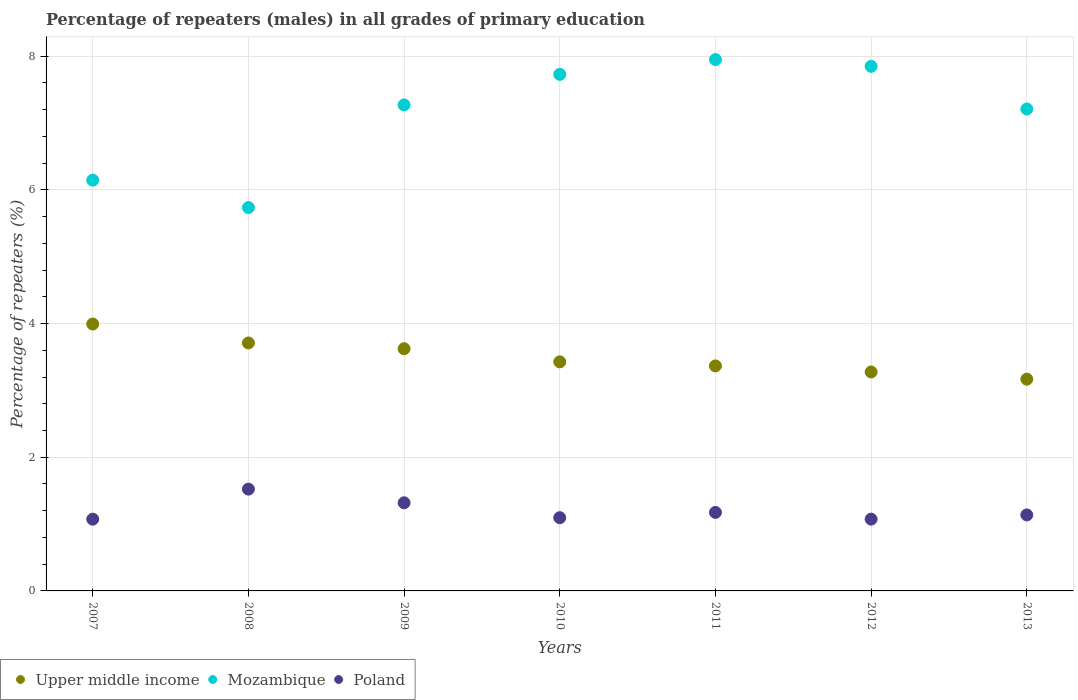What is the percentage of repeaters (males) in Mozambique in 2009?
Your answer should be compact. 7.27. Across all years, what is the maximum percentage of repeaters (males) in Mozambique?
Your answer should be very brief. 7.95. Across all years, what is the minimum percentage of repeaters (males) in Mozambique?
Provide a succinct answer. 5.74. What is the total percentage of repeaters (males) in Upper middle income in the graph?
Ensure brevity in your answer.  24.56. What is the difference between the percentage of repeaters (males) in Upper middle income in 2007 and that in 2011?
Your answer should be very brief. 0.63. What is the difference between the percentage of repeaters (males) in Poland in 2012 and the percentage of repeaters (males) in Mozambique in 2008?
Provide a succinct answer. -4.66. What is the average percentage of repeaters (males) in Upper middle income per year?
Offer a terse response. 3.51. In the year 2013, what is the difference between the percentage of repeaters (males) in Mozambique and percentage of repeaters (males) in Poland?
Make the answer very short. 6.07. What is the ratio of the percentage of repeaters (males) in Upper middle income in 2007 to that in 2011?
Your response must be concise. 1.19. Is the difference between the percentage of repeaters (males) in Mozambique in 2010 and 2012 greater than the difference between the percentage of repeaters (males) in Poland in 2010 and 2012?
Ensure brevity in your answer.  No. What is the difference between the highest and the second highest percentage of repeaters (males) in Mozambique?
Give a very brief answer. 0.1. What is the difference between the highest and the lowest percentage of repeaters (males) in Poland?
Your response must be concise. 0.45. Does the percentage of repeaters (males) in Mozambique monotonically increase over the years?
Make the answer very short. No. Is the percentage of repeaters (males) in Mozambique strictly less than the percentage of repeaters (males) in Poland over the years?
Keep it short and to the point. No. How many dotlines are there?
Give a very brief answer. 3. What is the difference between two consecutive major ticks on the Y-axis?
Provide a short and direct response. 2. Are the values on the major ticks of Y-axis written in scientific E-notation?
Offer a very short reply. No. Does the graph contain any zero values?
Provide a short and direct response. No. Does the graph contain grids?
Your answer should be compact. Yes. Where does the legend appear in the graph?
Provide a succinct answer. Bottom left. How many legend labels are there?
Make the answer very short. 3. What is the title of the graph?
Offer a very short reply. Percentage of repeaters (males) in all grades of primary education. Does "Bermuda" appear as one of the legend labels in the graph?
Offer a terse response. No. What is the label or title of the X-axis?
Your response must be concise. Years. What is the label or title of the Y-axis?
Ensure brevity in your answer.  Percentage of repeaters (%). What is the Percentage of repeaters (%) of Upper middle income in 2007?
Provide a succinct answer. 3.99. What is the Percentage of repeaters (%) in Mozambique in 2007?
Your answer should be very brief. 6.14. What is the Percentage of repeaters (%) in Poland in 2007?
Your response must be concise. 1.07. What is the Percentage of repeaters (%) in Upper middle income in 2008?
Offer a terse response. 3.71. What is the Percentage of repeaters (%) of Mozambique in 2008?
Your answer should be compact. 5.74. What is the Percentage of repeaters (%) in Poland in 2008?
Provide a short and direct response. 1.52. What is the Percentage of repeaters (%) in Upper middle income in 2009?
Your answer should be compact. 3.62. What is the Percentage of repeaters (%) of Mozambique in 2009?
Provide a short and direct response. 7.27. What is the Percentage of repeaters (%) of Poland in 2009?
Your response must be concise. 1.32. What is the Percentage of repeaters (%) of Upper middle income in 2010?
Your answer should be very brief. 3.43. What is the Percentage of repeaters (%) in Mozambique in 2010?
Ensure brevity in your answer.  7.73. What is the Percentage of repeaters (%) of Poland in 2010?
Offer a terse response. 1.1. What is the Percentage of repeaters (%) in Upper middle income in 2011?
Ensure brevity in your answer.  3.37. What is the Percentage of repeaters (%) of Mozambique in 2011?
Your answer should be compact. 7.95. What is the Percentage of repeaters (%) of Poland in 2011?
Keep it short and to the point. 1.17. What is the Percentage of repeaters (%) in Upper middle income in 2012?
Ensure brevity in your answer.  3.28. What is the Percentage of repeaters (%) of Mozambique in 2012?
Provide a succinct answer. 7.85. What is the Percentage of repeaters (%) of Poland in 2012?
Ensure brevity in your answer.  1.07. What is the Percentage of repeaters (%) in Upper middle income in 2013?
Provide a succinct answer. 3.17. What is the Percentage of repeaters (%) of Mozambique in 2013?
Offer a terse response. 7.21. What is the Percentage of repeaters (%) in Poland in 2013?
Make the answer very short. 1.14. Across all years, what is the maximum Percentage of repeaters (%) of Upper middle income?
Make the answer very short. 3.99. Across all years, what is the maximum Percentage of repeaters (%) of Mozambique?
Offer a terse response. 7.95. Across all years, what is the maximum Percentage of repeaters (%) of Poland?
Your answer should be compact. 1.52. Across all years, what is the minimum Percentage of repeaters (%) in Upper middle income?
Your answer should be very brief. 3.17. Across all years, what is the minimum Percentage of repeaters (%) in Mozambique?
Your answer should be compact. 5.74. Across all years, what is the minimum Percentage of repeaters (%) in Poland?
Your response must be concise. 1.07. What is the total Percentage of repeaters (%) of Upper middle income in the graph?
Keep it short and to the point. 24.56. What is the total Percentage of repeaters (%) in Mozambique in the graph?
Keep it short and to the point. 49.89. What is the total Percentage of repeaters (%) of Poland in the graph?
Ensure brevity in your answer.  8.4. What is the difference between the Percentage of repeaters (%) of Upper middle income in 2007 and that in 2008?
Your answer should be compact. 0.28. What is the difference between the Percentage of repeaters (%) in Mozambique in 2007 and that in 2008?
Provide a short and direct response. 0.41. What is the difference between the Percentage of repeaters (%) of Poland in 2007 and that in 2008?
Make the answer very short. -0.45. What is the difference between the Percentage of repeaters (%) of Upper middle income in 2007 and that in 2009?
Provide a short and direct response. 0.37. What is the difference between the Percentage of repeaters (%) in Mozambique in 2007 and that in 2009?
Offer a terse response. -1.13. What is the difference between the Percentage of repeaters (%) of Poland in 2007 and that in 2009?
Provide a short and direct response. -0.24. What is the difference between the Percentage of repeaters (%) of Upper middle income in 2007 and that in 2010?
Ensure brevity in your answer.  0.57. What is the difference between the Percentage of repeaters (%) of Mozambique in 2007 and that in 2010?
Ensure brevity in your answer.  -1.58. What is the difference between the Percentage of repeaters (%) in Poland in 2007 and that in 2010?
Make the answer very short. -0.02. What is the difference between the Percentage of repeaters (%) of Upper middle income in 2007 and that in 2011?
Make the answer very short. 0.63. What is the difference between the Percentage of repeaters (%) of Mozambique in 2007 and that in 2011?
Offer a terse response. -1.8. What is the difference between the Percentage of repeaters (%) of Poland in 2007 and that in 2011?
Keep it short and to the point. -0.1. What is the difference between the Percentage of repeaters (%) in Upper middle income in 2007 and that in 2012?
Offer a very short reply. 0.72. What is the difference between the Percentage of repeaters (%) of Mozambique in 2007 and that in 2012?
Give a very brief answer. -1.7. What is the difference between the Percentage of repeaters (%) of Poland in 2007 and that in 2012?
Provide a succinct answer. -0. What is the difference between the Percentage of repeaters (%) in Upper middle income in 2007 and that in 2013?
Your response must be concise. 0.82. What is the difference between the Percentage of repeaters (%) of Mozambique in 2007 and that in 2013?
Give a very brief answer. -1.06. What is the difference between the Percentage of repeaters (%) of Poland in 2007 and that in 2013?
Ensure brevity in your answer.  -0.06. What is the difference between the Percentage of repeaters (%) in Upper middle income in 2008 and that in 2009?
Ensure brevity in your answer.  0.09. What is the difference between the Percentage of repeaters (%) of Mozambique in 2008 and that in 2009?
Give a very brief answer. -1.54. What is the difference between the Percentage of repeaters (%) in Poland in 2008 and that in 2009?
Offer a terse response. 0.2. What is the difference between the Percentage of repeaters (%) in Upper middle income in 2008 and that in 2010?
Your answer should be very brief. 0.28. What is the difference between the Percentage of repeaters (%) in Mozambique in 2008 and that in 2010?
Your answer should be very brief. -1.99. What is the difference between the Percentage of repeaters (%) in Poland in 2008 and that in 2010?
Make the answer very short. 0.43. What is the difference between the Percentage of repeaters (%) in Upper middle income in 2008 and that in 2011?
Your response must be concise. 0.34. What is the difference between the Percentage of repeaters (%) in Mozambique in 2008 and that in 2011?
Your answer should be very brief. -2.21. What is the difference between the Percentage of repeaters (%) of Poland in 2008 and that in 2011?
Provide a short and direct response. 0.35. What is the difference between the Percentage of repeaters (%) in Upper middle income in 2008 and that in 2012?
Your answer should be compact. 0.43. What is the difference between the Percentage of repeaters (%) in Mozambique in 2008 and that in 2012?
Your answer should be very brief. -2.11. What is the difference between the Percentage of repeaters (%) of Poland in 2008 and that in 2012?
Offer a terse response. 0.45. What is the difference between the Percentage of repeaters (%) in Upper middle income in 2008 and that in 2013?
Offer a terse response. 0.54. What is the difference between the Percentage of repeaters (%) of Mozambique in 2008 and that in 2013?
Your response must be concise. -1.47. What is the difference between the Percentage of repeaters (%) of Poland in 2008 and that in 2013?
Ensure brevity in your answer.  0.39. What is the difference between the Percentage of repeaters (%) in Upper middle income in 2009 and that in 2010?
Your response must be concise. 0.2. What is the difference between the Percentage of repeaters (%) in Mozambique in 2009 and that in 2010?
Offer a terse response. -0.46. What is the difference between the Percentage of repeaters (%) in Poland in 2009 and that in 2010?
Keep it short and to the point. 0.22. What is the difference between the Percentage of repeaters (%) of Upper middle income in 2009 and that in 2011?
Your response must be concise. 0.26. What is the difference between the Percentage of repeaters (%) of Mozambique in 2009 and that in 2011?
Offer a terse response. -0.68. What is the difference between the Percentage of repeaters (%) of Poland in 2009 and that in 2011?
Provide a short and direct response. 0.14. What is the difference between the Percentage of repeaters (%) in Upper middle income in 2009 and that in 2012?
Offer a very short reply. 0.35. What is the difference between the Percentage of repeaters (%) in Mozambique in 2009 and that in 2012?
Give a very brief answer. -0.58. What is the difference between the Percentage of repeaters (%) in Poland in 2009 and that in 2012?
Offer a very short reply. 0.24. What is the difference between the Percentage of repeaters (%) in Upper middle income in 2009 and that in 2013?
Provide a succinct answer. 0.46. What is the difference between the Percentage of repeaters (%) in Mozambique in 2009 and that in 2013?
Keep it short and to the point. 0.06. What is the difference between the Percentage of repeaters (%) of Poland in 2009 and that in 2013?
Provide a succinct answer. 0.18. What is the difference between the Percentage of repeaters (%) in Upper middle income in 2010 and that in 2011?
Your answer should be very brief. 0.06. What is the difference between the Percentage of repeaters (%) of Mozambique in 2010 and that in 2011?
Make the answer very short. -0.22. What is the difference between the Percentage of repeaters (%) in Poland in 2010 and that in 2011?
Ensure brevity in your answer.  -0.08. What is the difference between the Percentage of repeaters (%) in Upper middle income in 2010 and that in 2012?
Make the answer very short. 0.15. What is the difference between the Percentage of repeaters (%) in Mozambique in 2010 and that in 2012?
Keep it short and to the point. -0.12. What is the difference between the Percentage of repeaters (%) in Poland in 2010 and that in 2012?
Offer a very short reply. 0.02. What is the difference between the Percentage of repeaters (%) in Upper middle income in 2010 and that in 2013?
Your response must be concise. 0.26. What is the difference between the Percentage of repeaters (%) of Mozambique in 2010 and that in 2013?
Your answer should be compact. 0.52. What is the difference between the Percentage of repeaters (%) of Poland in 2010 and that in 2013?
Provide a succinct answer. -0.04. What is the difference between the Percentage of repeaters (%) of Upper middle income in 2011 and that in 2012?
Provide a succinct answer. 0.09. What is the difference between the Percentage of repeaters (%) in Mozambique in 2011 and that in 2012?
Your answer should be compact. 0.1. What is the difference between the Percentage of repeaters (%) of Poland in 2011 and that in 2012?
Make the answer very short. 0.1. What is the difference between the Percentage of repeaters (%) of Upper middle income in 2011 and that in 2013?
Offer a very short reply. 0.2. What is the difference between the Percentage of repeaters (%) in Mozambique in 2011 and that in 2013?
Your answer should be compact. 0.74. What is the difference between the Percentage of repeaters (%) in Poland in 2011 and that in 2013?
Your answer should be very brief. 0.04. What is the difference between the Percentage of repeaters (%) in Upper middle income in 2012 and that in 2013?
Keep it short and to the point. 0.11. What is the difference between the Percentage of repeaters (%) of Mozambique in 2012 and that in 2013?
Offer a very short reply. 0.64. What is the difference between the Percentage of repeaters (%) of Poland in 2012 and that in 2013?
Offer a terse response. -0.06. What is the difference between the Percentage of repeaters (%) in Upper middle income in 2007 and the Percentage of repeaters (%) in Mozambique in 2008?
Offer a terse response. -1.74. What is the difference between the Percentage of repeaters (%) in Upper middle income in 2007 and the Percentage of repeaters (%) in Poland in 2008?
Your answer should be very brief. 2.47. What is the difference between the Percentage of repeaters (%) of Mozambique in 2007 and the Percentage of repeaters (%) of Poland in 2008?
Your response must be concise. 4.62. What is the difference between the Percentage of repeaters (%) of Upper middle income in 2007 and the Percentage of repeaters (%) of Mozambique in 2009?
Your answer should be compact. -3.28. What is the difference between the Percentage of repeaters (%) in Upper middle income in 2007 and the Percentage of repeaters (%) in Poland in 2009?
Give a very brief answer. 2.67. What is the difference between the Percentage of repeaters (%) in Mozambique in 2007 and the Percentage of repeaters (%) in Poland in 2009?
Ensure brevity in your answer.  4.83. What is the difference between the Percentage of repeaters (%) in Upper middle income in 2007 and the Percentage of repeaters (%) in Mozambique in 2010?
Keep it short and to the point. -3.73. What is the difference between the Percentage of repeaters (%) in Upper middle income in 2007 and the Percentage of repeaters (%) in Poland in 2010?
Make the answer very short. 2.9. What is the difference between the Percentage of repeaters (%) of Mozambique in 2007 and the Percentage of repeaters (%) of Poland in 2010?
Offer a very short reply. 5.05. What is the difference between the Percentage of repeaters (%) of Upper middle income in 2007 and the Percentage of repeaters (%) of Mozambique in 2011?
Ensure brevity in your answer.  -3.96. What is the difference between the Percentage of repeaters (%) of Upper middle income in 2007 and the Percentage of repeaters (%) of Poland in 2011?
Provide a succinct answer. 2.82. What is the difference between the Percentage of repeaters (%) of Mozambique in 2007 and the Percentage of repeaters (%) of Poland in 2011?
Provide a short and direct response. 4.97. What is the difference between the Percentage of repeaters (%) of Upper middle income in 2007 and the Percentage of repeaters (%) of Mozambique in 2012?
Offer a terse response. -3.86. What is the difference between the Percentage of repeaters (%) in Upper middle income in 2007 and the Percentage of repeaters (%) in Poland in 2012?
Give a very brief answer. 2.92. What is the difference between the Percentage of repeaters (%) in Mozambique in 2007 and the Percentage of repeaters (%) in Poland in 2012?
Provide a short and direct response. 5.07. What is the difference between the Percentage of repeaters (%) of Upper middle income in 2007 and the Percentage of repeaters (%) of Mozambique in 2013?
Your response must be concise. -3.22. What is the difference between the Percentage of repeaters (%) of Upper middle income in 2007 and the Percentage of repeaters (%) of Poland in 2013?
Give a very brief answer. 2.86. What is the difference between the Percentage of repeaters (%) in Mozambique in 2007 and the Percentage of repeaters (%) in Poland in 2013?
Provide a short and direct response. 5.01. What is the difference between the Percentage of repeaters (%) of Upper middle income in 2008 and the Percentage of repeaters (%) of Mozambique in 2009?
Your answer should be very brief. -3.56. What is the difference between the Percentage of repeaters (%) in Upper middle income in 2008 and the Percentage of repeaters (%) in Poland in 2009?
Offer a terse response. 2.39. What is the difference between the Percentage of repeaters (%) in Mozambique in 2008 and the Percentage of repeaters (%) in Poland in 2009?
Provide a short and direct response. 4.42. What is the difference between the Percentage of repeaters (%) of Upper middle income in 2008 and the Percentage of repeaters (%) of Mozambique in 2010?
Your response must be concise. -4.02. What is the difference between the Percentage of repeaters (%) in Upper middle income in 2008 and the Percentage of repeaters (%) in Poland in 2010?
Your answer should be very brief. 2.61. What is the difference between the Percentage of repeaters (%) of Mozambique in 2008 and the Percentage of repeaters (%) of Poland in 2010?
Provide a succinct answer. 4.64. What is the difference between the Percentage of repeaters (%) of Upper middle income in 2008 and the Percentage of repeaters (%) of Mozambique in 2011?
Ensure brevity in your answer.  -4.24. What is the difference between the Percentage of repeaters (%) of Upper middle income in 2008 and the Percentage of repeaters (%) of Poland in 2011?
Your answer should be very brief. 2.53. What is the difference between the Percentage of repeaters (%) in Mozambique in 2008 and the Percentage of repeaters (%) in Poland in 2011?
Your answer should be very brief. 4.56. What is the difference between the Percentage of repeaters (%) in Upper middle income in 2008 and the Percentage of repeaters (%) in Mozambique in 2012?
Your response must be concise. -4.14. What is the difference between the Percentage of repeaters (%) of Upper middle income in 2008 and the Percentage of repeaters (%) of Poland in 2012?
Your response must be concise. 2.64. What is the difference between the Percentage of repeaters (%) of Mozambique in 2008 and the Percentage of repeaters (%) of Poland in 2012?
Provide a short and direct response. 4.66. What is the difference between the Percentage of repeaters (%) of Upper middle income in 2008 and the Percentage of repeaters (%) of Mozambique in 2013?
Your answer should be compact. -3.5. What is the difference between the Percentage of repeaters (%) in Upper middle income in 2008 and the Percentage of repeaters (%) in Poland in 2013?
Make the answer very short. 2.57. What is the difference between the Percentage of repeaters (%) of Mozambique in 2008 and the Percentage of repeaters (%) of Poland in 2013?
Provide a short and direct response. 4.6. What is the difference between the Percentage of repeaters (%) of Upper middle income in 2009 and the Percentage of repeaters (%) of Mozambique in 2010?
Your response must be concise. -4.1. What is the difference between the Percentage of repeaters (%) of Upper middle income in 2009 and the Percentage of repeaters (%) of Poland in 2010?
Offer a very short reply. 2.53. What is the difference between the Percentage of repeaters (%) in Mozambique in 2009 and the Percentage of repeaters (%) in Poland in 2010?
Provide a succinct answer. 6.18. What is the difference between the Percentage of repeaters (%) of Upper middle income in 2009 and the Percentage of repeaters (%) of Mozambique in 2011?
Provide a short and direct response. -4.33. What is the difference between the Percentage of repeaters (%) of Upper middle income in 2009 and the Percentage of repeaters (%) of Poland in 2011?
Give a very brief answer. 2.45. What is the difference between the Percentage of repeaters (%) in Mozambique in 2009 and the Percentage of repeaters (%) in Poland in 2011?
Ensure brevity in your answer.  6.1. What is the difference between the Percentage of repeaters (%) of Upper middle income in 2009 and the Percentage of repeaters (%) of Mozambique in 2012?
Ensure brevity in your answer.  -4.22. What is the difference between the Percentage of repeaters (%) in Upper middle income in 2009 and the Percentage of repeaters (%) in Poland in 2012?
Provide a succinct answer. 2.55. What is the difference between the Percentage of repeaters (%) of Mozambique in 2009 and the Percentage of repeaters (%) of Poland in 2012?
Offer a very short reply. 6.2. What is the difference between the Percentage of repeaters (%) in Upper middle income in 2009 and the Percentage of repeaters (%) in Mozambique in 2013?
Your answer should be compact. -3.59. What is the difference between the Percentage of repeaters (%) of Upper middle income in 2009 and the Percentage of repeaters (%) of Poland in 2013?
Make the answer very short. 2.49. What is the difference between the Percentage of repeaters (%) of Mozambique in 2009 and the Percentage of repeaters (%) of Poland in 2013?
Offer a very short reply. 6.13. What is the difference between the Percentage of repeaters (%) in Upper middle income in 2010 and the Percentage of repeaters (%) in Mozambique in 2011?
Give a very brief answer. -4.52. What is the difference between the Percentage of repeaters (%) in Upper middle income in 2010 and the Percentage of repeaters (%) in Poland in 2011?
Keep it short and to the point. 2.25. What is the difference between the Percentage of repeaters (%) of Mozambique in 2010 and the Percentage of repeaters (%) of Poland in 2011?
Make the answer very short. 6.55. What is the difference between the Percentage of repeaters (%) of Upper middle income in 2010 and the Percentage of repeaters (%) of Mozambique in 2012?
Your answer should be compact. -4.42. What is the difference between the Percentage of repeaters (%) in Upper middle income in 2010 and the Percentage of repeaters (%) in Poland in 2012?
Make the answer very short. 2.35. What is the difference between the Percentage of repeaters (%) of Mozambique in 2010 and the Percentage of repeaters (%) of Poland in 2012?
Ensure brevity in your answer.  6.65. What is the difference between the Percentage of repeaters (%) in Upper middle income in 2010 and the Percentage of repeaters (%) in Mozambique in 2013?
Give a very brief answer. -3.78. What is the difference between the Percentage of repeaters (%) of Upper middle income in 2010 and the Percentage of repeaters (%) of Poland in 2013?
Ensure brevity in your answer.  2.29. What is the difference between the Percentage of repeaters (%) in Mozambique in 2010 and the Percentage of repeaters (%) in Poland in 2013?
Give a very brief answer. 6.59. What is the difference between the Percentage of repeaters (%) of Upper middle income in 2011 and the Percentage of repeaters (%) of Mozambique in 2012?
Ensure brevity in your answer.  -4.48. What is the difference between the Percentage of repeaters (%) of Upper middle income in 2011 and the Percentage of repeaters (%) of Poland in 2012?
Offer a very short reply. 2.29. What is the difference between the Percentage of repeaters (%) in Mozambique in 2011 and the Percentage of repeaters (%) in Poland in 2012?
Offer a terse response. 6.88. What is the difference between the Percentage of repeaters (%) of Upper middle income in 2011 and the Percentage of repeaters (%) of Mozambique in 2013?
Your response must be concise. -3.84. What is the difference between the Percentage of repeaters (%) in Upper middle income in 2011 and the Percentage of repeaters (%) in Poland in 2013?
Ensure brevity in your answer.  2.23. What is the difference between the Percentage of repeaters (%) in Mozambique in 2011 and the Percentage of repeaters (%) in Poland in 2013?
Make the answer very short. 6.81. What is the difference between the Percentage of repeaters (%) of Upper middle income in 2012 and the Percentage of repeaters (%) of Mozambique in 2013?
Ensure brevity in your answer.  -3.93. What is the difference between the Percentage of repeaters (%) of Upper middle income in 2012 and the Percentage of repeaters (%) of Poland in 2013?
Provide a succinct answer. 2.14. What is the difference between the Percentage of repeaters (%) of Mozambique in 2012 and the Percentage of repeaters (%) of Poland in 2013?
Make the answer very short. 6.71. What is the average Percentage of repeaters (%) of Upper middle income per year?
Your response must be concise. 3.51. What is the average Percentage of repeaters (%) in Mozambique per year?
Make the answer very short. 7.13. What is the average Percentage of repeaters (%) in Poland per year?
Your answer should be compact. 1.2. In the year 2007, what is the difference between the Percentage of repeaters (%) of Upper middle income and Percentage of repeaters (%) of Mozambique?
Ensure brevity in your answer.  -2.15. In the year 2007, what is the difference between the Percentage of repeaters (%) in Upper middle income and Percentage of repeaters (%) in Poland?
Offer a terse response. 2.92. In the year 2007, what is the difference between the Percentage of repeaters (%) in Mozambique and Percentage of repeaters (%) in Poland?
Keep it short and to the point. 5.07. In the year 2008, what is the difference between the Percentage of repeaters (%) in Upper middle income and Percentage of repeaters (%) in Mozambique?
Offer a very short reply. -2.03. In the year 2008, what is the difference between the Percentage of repeaters (%) in Upper middle income and Percentage of repeaters (%) in Poland?
Provide a succinct answer. 2.19. In the year 2008, what is the difference between the Percentage of repeaters (%) of Mozambique and Percentage of repeaters (%) of Poland?
Keep it short and to the point. 4.21. In the year 2009, what is the difference between the Percentage of repeaters (%) of Upper middle income and Percentage of repeaters (%) of Mozambique?
Ensure brevity in your answer.  -3.65. In the year 2009, what is the difference between the Percentage of repeaters (%) in Upper middle income and Percentage of repeaters (%) in Poland?
Make the answer very short. 2.3. In the year 2009, what is the difference between the Percentage of repeaters (%) of Mozambique and Percentage of repeaters (%) of Poland?
Keep it short and to the point. 5.95. In the year 2010, what is the difference between the Percentage of repeaters (%) in Upper middle income and Percentage of repeaters (%) in Mozambique?
Give a very brief answer. -4.3. In the year 2010, what is the difference between the Percentage of repeaters (%) of Upper middle income and Percentage of repeaters (%) of Poland?
Provide a succinct answer. 2.33. In the year 2010, what is the difference between the Percentage of repeaters (%) of Mozambique and Percentage of repeaters (%) of Poland?
Provide a short and direct response. 6.63. In the year 2011, what is the difference between the Percentage of repeaters (%) of Upper middle income and Percentage of repeaters (%) of Mozambique?
Your response must be concise. -4.58. In the year 2011, what is the difference between the Percentage of repeaters (%) in Upper middle income and Percentage of repeaters (%) in Poland?
Your response must be concise. 2.19. In the year 2011, what is the difference between the Percentage of repeaters (%) in Mozambique and Percentage of repeaters (%) in Poland?
Your answer should be compact. 6.77. In the year 2012, what is the difference between the Percentage of repeaters (%) in Upper middle income and Percentage of repeaters (%) in Mozambique?
Provide a succinct answer. -4.57. In the year 2012, what is the difference between the Percentage of repeaters (%) in Upper middle income and Percentage of repeaters (%) in Poland?
Ensure brevity in your answer.  2.2. In the year 2012, what is the difference between the Percentage of repeaters (%) of Mozambique and Percentage of repeaters (%) of Poland?
Your answer should be compact. 6.77. In the year 2013, what is the difference between the Percentage of repeaters (%) of Upper middle income and Percentage of repeaters (%) of Mozambique?
Provide a succinct answer. -4.04. In the year 2013, what is the difference between the Percentage of repeaters (%) of Upper middle income and Percentage of repeaters (%) of Poland?
Your answer should be compact. 2.03. In the year 2013, what is the difference between the Percentage of repeaters (%) in Mozambique and Percentage of repeaters (%) in Poland?
Offer a terse response. 6.07. What is the ratio of the Percentage of repeaters (%) of Upper middle income in 2007 to that in 2008?
Offer a very short reply. 1.08. What is the ratio of the Percentage of repeaters (%) of Mozambique in 2007 to that in 2008?
Make the answer very short. 1.07. What is the ratio of the Percentage of repeaters (%) in Poland in 2007 to that in 2008?
Offer a terse response. 0.7. What is the ratio of the Percentage of repeaters (%) of Upper middle income in 2007 to that in 2009?
Your response must be concise. 1.1. What is the ratio of the Percentage of repeaters (%) in Mozambique in 2007 to that in 2009?
Give a very brief answer. 0.85. What is the ratio of the Percentage of repeaters (%) of Poland in 2007 to that in 2009?
Offer a terse response. 0.81. What is the ratio of the Percentage of repeaters (%) of Upper middle income in 2007 to that in 2010?
Offer a very short reply. 1.17. What is the ratio of the Percentage of repeaters (%) in Mozambique in 2007 to that in 2010?
Keep it short and to the point. 0.8. What is the ratio of the Percentage of repeaters (%) in Poland in 2007 to that in 2010?
Offer a terse response. 0.98. What is the ratio of the Percentage of repeaters (%) of Upper middle income in 2007 to that in 2011?
Your answer should be very brief. 1.19. What is the ratio of the Percentage of repeaters (%) in Mozambique in 2007 to that in 2011?
Your answer should be very brief. 0.77. What is the ratio of the Percentage of repeaters (%) of Poland in 2007 to that in 2011?
Your answer should be compact. 0.91. What is the ratio of the Percentage of repeaters (%) in Upper middle income in 2007 to that in 2012?
Provide a succinct answer. 1.22. What is the ratio of the Percentage of repeaters (%) of Mozambique in 2007 to that in 2012?
Give a very brief answer. 0.78. What is the ratio of the Percentage of repeaters (%) of Upper middle income in 2007 to that in 2013?
Give a very brief answer. 1.26. What is the ratio of the Percentage of repeaters (%) in Mozambique in 2007 to that in 2013?
Your response must be concise. 0.85. What is the ratio of the Percentage of repeaters (%) of Poland in 2007 to that in 2013?
Provide a short and direct response. 0.94. What is the ratio of the Percentage of repeaters (%) of Upper middle income in 2008 to that in 2009?
Provide a short and direct response. 1.02. What is the ratio of the Percentage of repeaters (%) of Mozambique in 2008 to that in 2009?
Give a very brief answer. 0.79. What is the ratio of the Percentage of repeaters (%) of Poland in 2008 to that in 2009?
Your response must be concise. 1.16. What is the ratio of the Percentage of repeaters (%) of Upper middle income in 2008 to that in 2010?
Your response must be concise. 1.08. What is the ratio of the Percentage of repeaters (%) in Mozambique in 2008 to that in 2010?
Provide a succinct answer. 0.74. What is the ratio of the Percentage of repeaters (%) of Poland in 2008 to that in 2010?
Your answer should be compact. 1.39. What is the ratio of the Percentage of repeaters (%) in Upper middle income in 2008 to that in 2011?
Provide a succinct answer. 1.1. What is the ratio of the Percentage of repeaters (%) in Mozambique in 2008 to that in 2011?
Keep it short and to the point. 0.72. What is the ratio of the Percentage of repeaters (%) in Poland in 2008 to that in 2011?
Your answer should be very brief. 1.3. What is the ratio of the Percentage of repeaters (%) in Upper middle income in 2008 to that in 2012?
Ensure brevity in your answer.  1.13. What is the ratio of the Percentage of repeaters (%) of Mozambique in 2008 to that in 2012?
Provide a short and direct response. 0.73. What is the ratio of the Percentage of repeaters (%) in Poland in 2008 to that in 2012?
Provide a short and direct response. 1.42. What is the ratio of the Percentage of repeaters (%) of Upper middle income in 2008 to that in 2013?
Ensure brevity in your answer.  1.17. What is the ratio of the Percentage of repeaters (%) of Mozambique in 2008 to that in 2013?
Give a very brief answer. 0.8. What is the ratio of the Percentage of repeaters (%) of Poland in 2008 to that in 2013?
Provide a succinct answer. 1.34. What is the ratio of the Percentage of repeaters (%) of Upper middle income in 2009 to that in 2010?
Your answer should be very brief. 1.06. What is the ratio of the Percentage of repeaters (%) of Mozambique in 2009 to that in 2010?
Offer a very short reply. 0.94. What is the ratio of the Percentage of repeaters (%) of Poland in 2009 to that in 2010?
Keep it short and to the point. 1.2. What is the ratio of the Percentage of repeaters (%) of Upper middle income in 2009 to that in 2011?
Make the answer very short. 1.08. What is the ratio of the Percentage of repeaters (%) in Mozambique in 2009 to that in 2011?
Keep it short and to the point. 0.91. What is the ratio of the Percentage of repeaters (%) in Poland in 2009 to that in 2011?
Provide a short and direct response. 1.12. What is the ratio of the Percentage of repeaters (%) in Upper middle income in 2009 to that in 2012?
Your answer should be compact. 1.11. What is the ratio of the Percentage of repeaters (%) of Mozambique in 2009 to that in 2012?
Keep it short and to the point. 0.93. What is the ratio of the Percentage of repeaters (%) in Poland in 2009 to that in 2012?
Offer a very short reply. 1.23. What is the ratio of the Percentage of repeaters (%) of Upper middle income in 2009 to that in 2013?
Provide a short and direct response. 1.14. What is the ratio of the Percentage of repeaters (%) in Mozambique in 2009 to that in 2013?
Your response must be concise. 1.01. What is the ratio of the Percentage of repeaters (%) of Poland in 2009 to that in 2013?
Provide a short and direct response. 1.16. What is the ratio of the Percentage of repeaters (%) in Upper middle income in 2010 to that in 2011?
Your answer should be very brief. 1.02. What is the ratio of the Percentage of repeaters (%) in Mozambique in 2010 to that in 2011?
Provide a succinct answer. 0.97. What is the ratio of the Percentage of repeaters (%) in Poland in 2010 to that in 2011?
Provide a succinct answer. 0.93. What is the ratio of the Percentage of repeaters (%) in Upper middle income in 2010 to that in 2012?
Offer a terse response. 1.05. What is the ratio of the Percentage of repeaters (%) of Mozambique in 2010 to that in 2012?
Your answer should be very brief. 0.98. What is the ratio of the Percentage of repeaters (%) of Poland in 2010 to that in 2012?
Provide a short and direct response. 1.02. What is the ratio of the Percentage of repeaters (%) of Upper middle income in 2010 to that in 2013?
Give a very brief answer. 1.08. What is the ratio of the Percentage of repeaters (%) in Mozambique in 2010 to that in 2013?
Offer a very short reply. 1.07. What is the ratio of the Percentage of repeaters (%) of Poland in 2010 to that in 2013?
Your answer should be compact. 0.96. What is the ratio of the Percentage of repeaters (%) in Upper middle income in 2011 to that in 2012?
Keep it short and to the point. 1.03. What is the ratio of the Percentage of repeaters (%) of Mozambique in 2011 to that in 2012?
Provide a succinct answer. 1.01. What is the ratio of the Percentage of repeaters (%) of Poland in 2011 to that in 2012?
Offer a very short reply. 1.09. What is the ratio of the Percentage of repeaters (%) of Upper middle income in 2011 to that in 2013?
Give a very brief answer. 1.06. What is the ratio of the Percentage of repeaters (%) of Mozambique in 2011 to that in 2013?
Your response must be concise. 1.1. What is the ratio of the Percentage of repeaters (%) of Poland in 2011 to that in 2013?
Keep it short and to the point. 1.03. What is the ratio of the Percentage of repeaters (%) in Upper middle income in 2012 to that in 2013?
Your response must be concise. 1.03. What is the ratio of the Percentage of repeaters (%) in Mozambique in 2012 to that in 2013?
Offer a very short reply. 1.09. What is the ratio of the Percentage of repeaters (%) in Poland in 2012 to that in 2013?
Your answer should be compact. 0.94. What is the difference between the highest and the second highest Percentage of repeaters (%) of Upper middle income?
Keep it short and to the point. 0.28. What is the difference between the highest and the second highest Percentage of repeaters (%) of Mozambique?
Make the answer very short. 0.1. What is the difference between the highest and the second highest Percentage of repeaters (%) in Poland?
Offer a terse response. 0.2. What is the difference between the highest and the lowest Percentage of repeaters (%) in Upper middle income?
Give a very brief answer. 0.82. What is the difference between the highest and the lowest Percentage of repeaters (%) of Mozambique?
Ensure brevity in your answer.  2.21. What is the difference between the highest and the lowest Percentage of repeaters (%) of Poland?
Keep it short and to the point. 0.45. 